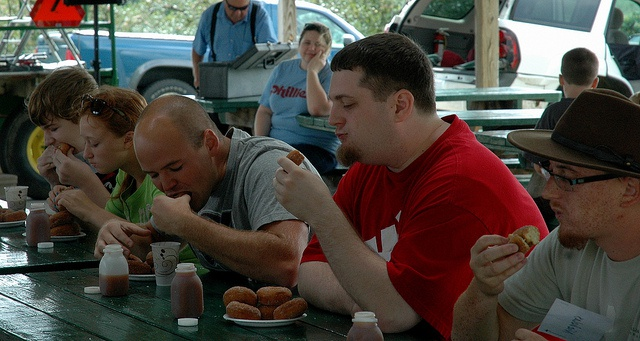Describe the objects in this image and their specific colors. I can see people in beige, maroon, black, and gray tones, people in beige, black, maroon, and gray tones, people in beige, black, maroon, and gray tones, dining table in beige, black, gray, maroon, and teal tones, and car in beige, white, gray, teal, and black tones in this image. 